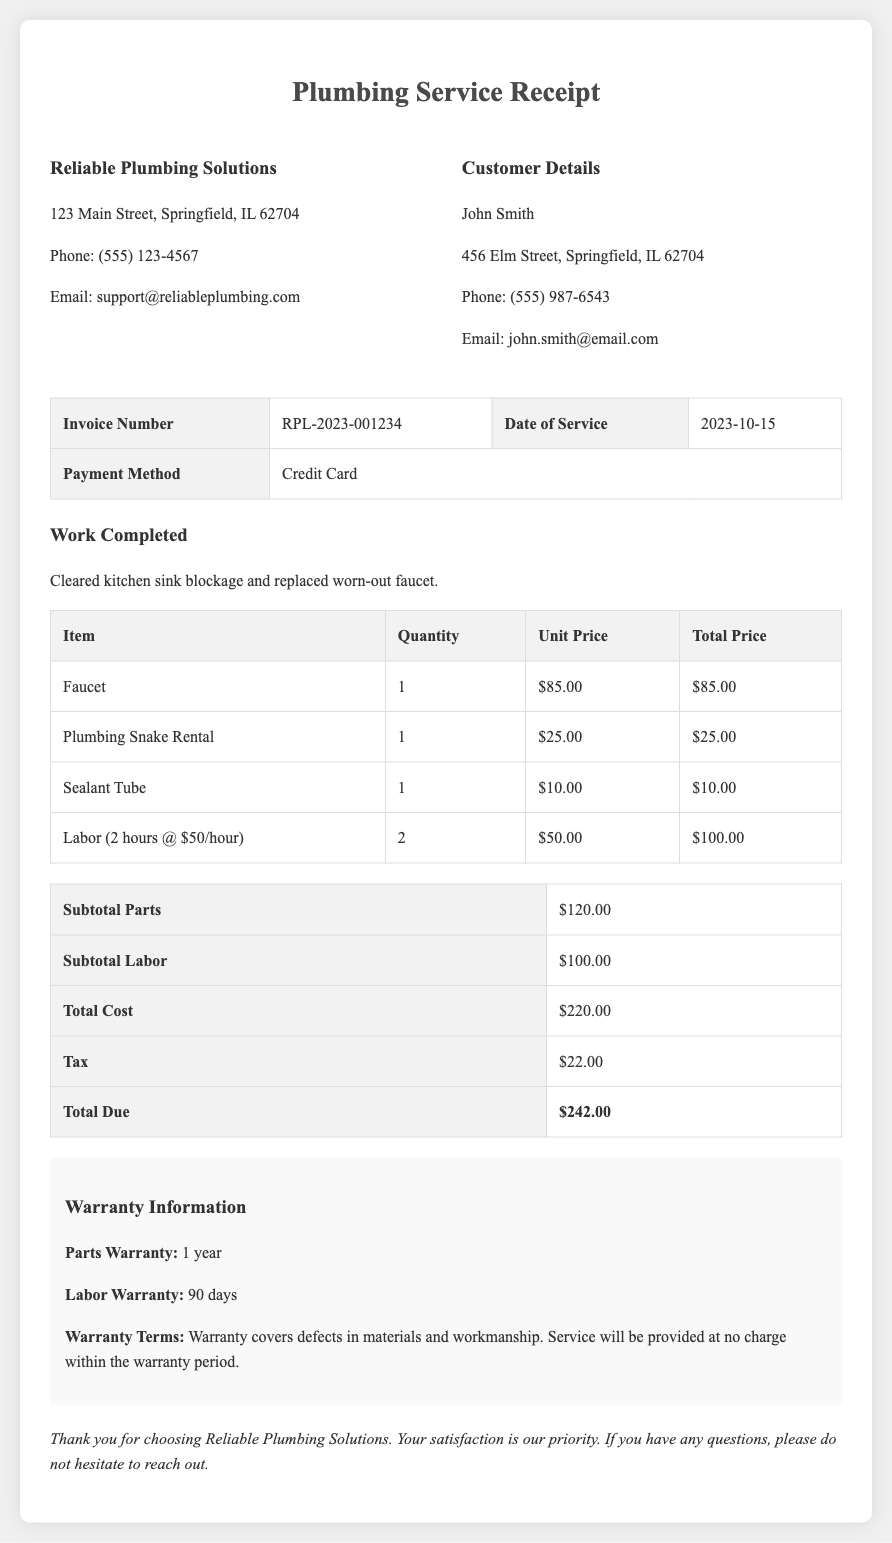What is the name of the company? The company's name is located at the top of the document under the company information section.
Answer: Reliable Plumbing Solutions What is the invoice number? The invoice number is specified in the table under the service details.
Answer: RPL-2023-001234 What is the total cost of parts? The total cost of parts is indicated in the table of costs.
Answer: $120.00 How many hours of labor were charged? The labor details mention the hours and rate in the labor description within the itemized pricing.
Answer: 2 What is the warranty period for parts? The warranty information section provides details on the warranty period for parts.
Answer: 1 year What is the total due amount? The final amount due is clearly stated in the total cost table.
Answer: $242.00 What was the date of service? The date of service is mentioned in the invoice details table.
Answer: 2023-10-15 What type of payment was used? The payment method is provided in the service details section of the document.
Answer: Credit Card What is the labor warranty duration? The warranty information specifies details regarding the duration of labor warranty.
Answer: 90 days 